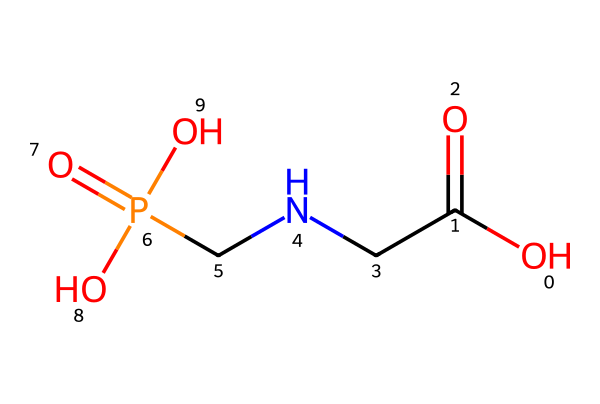What is the molecular formula of glyphosate? To determine the molecular formula, count the number of each type of atom present in the SMILES representation. The components are carbon (C), hydrogen (H), nitrogen (N), oxygen (O), and phosphorus (P). The counts are: C: 3, H: 8, N: 1, O: 4, P: 1. Therefore, the molecular formula is C3H8N1O4P1.
Answer: C3H8N1O4P1 How many oxygen atoms are in glyphosate? By examining the SMILES representation, we can see the "O" symbols. There are four discrete "O" symbols in the structure, indicating the presence of four oxygen atoms.
Answer: 4 What type of functional group is present in glyphosate? Analyzing the structure, we identify the presence of a carboxylic acid functional group (–COOH), and also a phosphonic acid functional group. Functional groups are specific groups of atoms that confer certain properties to a molecule. Both groups impact glyphosate's activity as an herbicide.
Answer: carboxylic and phosphonic acid What is the significance of the phosphorus atom in glyphosate? The phosphorus atom connects with oxygen atoms from the phosphonic acid group. Phosphorus is critical in glyphosate’s mechanism of action, as it participates in binding mechanisms with the target enzyme pathway in plants. Thus, it plays a key role in glyphosate's herbicidal activity.
Answer: herbicidal activity How many carbon atoms are in glyphosate? The SMILES representation contains three "C" symbols. We can count them directly to find there are three carbon atoms in the structure of glyphosate.
Answer: 3 What type of pesticide is glyphosate classified as? Glyphosate is classified as a non-selective systemic herbicide that effectively controls a broad range of weeds. This classification is derived from its chemical properties and the specific target sites.
Answer: non-selective systemic herbicide 